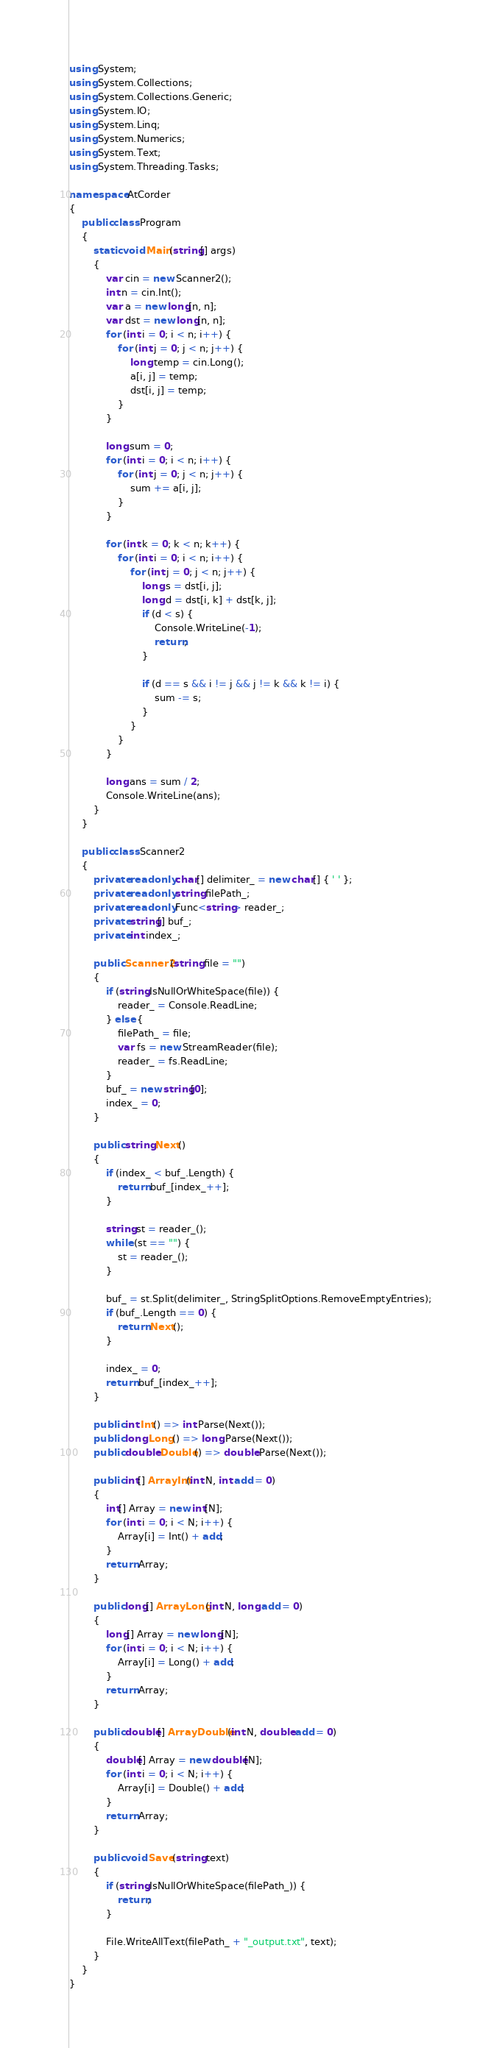<code> <loc_0><loc_0><loc_500><loc_500><_C#_>using System;
using System.Collections;
using System.Collections.Generic;
using System.IO;
using System.Linq;
using System.Numerics;
using System.Text;
using System.Threading.Tasks;

namespace AtCorder
{
	public class Program
	{
		static void Main(string[] args)
		{
			var cin = new Scanner2();
			int n = cin.Int();
			var a = new long[n, n];
			var dst = new long[n, n];
			for (int i = 0; i < n; i++) {
				for (int j = 0; j < n; j++) {
					long temp = cin.Long();
					a[i, j] = temp;
					dst[i, j] = temp;
				}
			}

			long sum = 0;
			for (int i = 0; i < n; i++) {
				for (int j = 0; j < n; j++) {
					sum += a[i, j];
				}
			}

			for (int k = 0; k < n; k++) {
				for (int i = 0; i < n; i++) {
					for (int j = 0; j < n; j++) {
						long s = dst[i, j];
						long d = dst[i, k] + dst[k, j];
						if (d < s) {
							Console.WriteLine(-1);
							return;
						}

						if (d == s && i != j && j != k && k != i) {
							sum -= s;
						}
					}
				}
			}

			long ans = sum / 2;
			Console.WriteLine(ans);
		}
	}

	public class Scanner2
	{
		private readonly char[] delimiter_ = new char[] { ' ' };
		private readonly string filePath_;
		private readonly Func<string> reader_;
		private string[] buf_;
		private int index_;

		public Scanner2(string file = "")
		{
			if (string.IsNullOrWhiteSpace(file)) {
				reader_ = Console.ReadLine;
			} else {
				filePath_ = file;
				var fs = new StreamReader(file);
				reader_ = fs.ReadLine;
			}
			buf_ = new string[0];
			index_ = 0;
		}

		public string Next()
		{
			if (index_ < buf_.Length) {
				return buf_[index_++];
			}

			string st = reader_();
			while (st == "") {
				st = reader_();
			}

			buf_ = st.Split(delimiter_, StringSplitOptions.RemoveEmptyEntries);
			if (buf_.Length == 0) {
				return Next();
			}

			index_ = 0;
			return buf_[index_++];
		}

		public int Int() => int.Parse(Next());
		public long Long() => long.Parse(Next());
		public double Double() => double.Parse(Next());

		public int[] ArrayInt(int N, int add = 0)
		{
			int[] Array = new int[N];
			for (int i = 0; i < N; i++) {
				Array[i] = Int() + add;
			}
			return Array;
		}

		public long[] ArrayLong(int N, long add = 0)
		{
			long[] Array = new long[N];
			for (int i = 0; i < N; i++) {
				Array[i] = Long() + add;
			}
			return Array;
		}

		public double[] ArrayDouble(int N, double add = 0)
		{
			double[] Array = new double[N];
			for (int i = 0; i < N; i++) {
				Array[i] = Double() + add;
			}
			return Array;
		}

		public void Save(string text)
		{
			if (string.IsNullOrWhiteSpace(filePath_)) {
				return;
			}

			File.WriteAllText(filePath_ + "_output.txt", text);
		}
	}
}</code> 